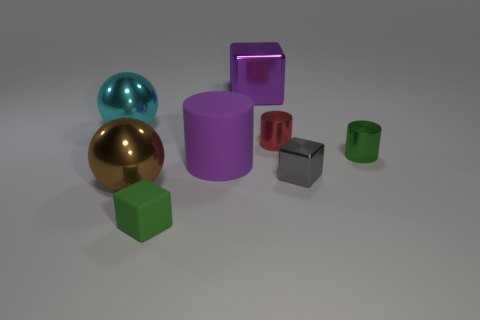Does the big matte cylinder have the same color as the matte block?
Offer a very short reply. No. How big is the green thing on the right side of the purple thing behind the small green metal object?
Your response must be concise. Small. Do the tiny block right of the green rubber object and the cube that is in front of the small gray cube have the same material?
Ensure brevity in your answer.  No. There is a sphere that is in front of the green metallic thing; is it the same color as the large matte thing?
Ensure brevity in your answer.  No. What number of small rubber things are right of the gray cube?
Provide a succinct answer. 0. Are the tiny red cylinder and the tiny cube behind the tiny rubber object made of the same material?
Your response must be concise. Yes. What is the size of the brown sphere that is made of the same material as the tiny gray block?
Your answer should be very brief. Large. Are there more big purple blocks that are on the left side of the big metallic block than blocks behind the cyan thing?
Your answer should be compact. No. Are there any other tiny green objects of the same shape as the green matte object?
Keep it short and to the point. No. There is a green metallic cylinder on the right side of the purple cylinder; does it have the same size as the cyan sphere?
Ensure brevity in your answer.  No. 